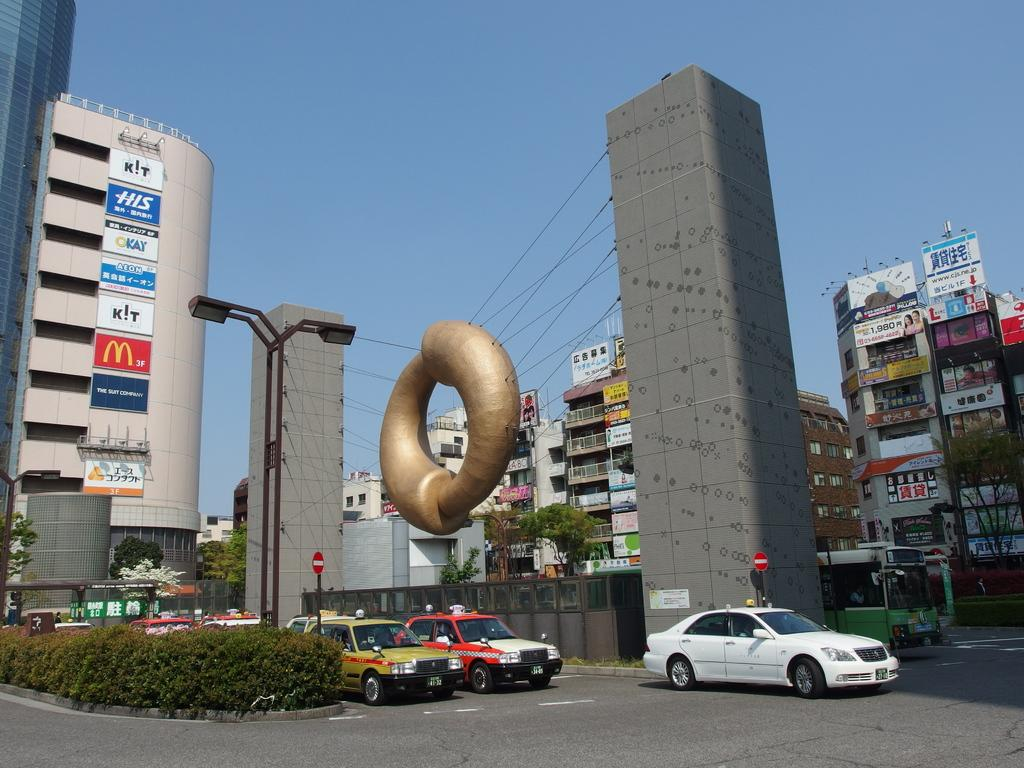<image>
Offer a succinct explanation of the picture presented. A circular shaped sculpture hangs near a tall building with signs on it that say, "k!t", "M 3F", "Kay", and "AEON". 